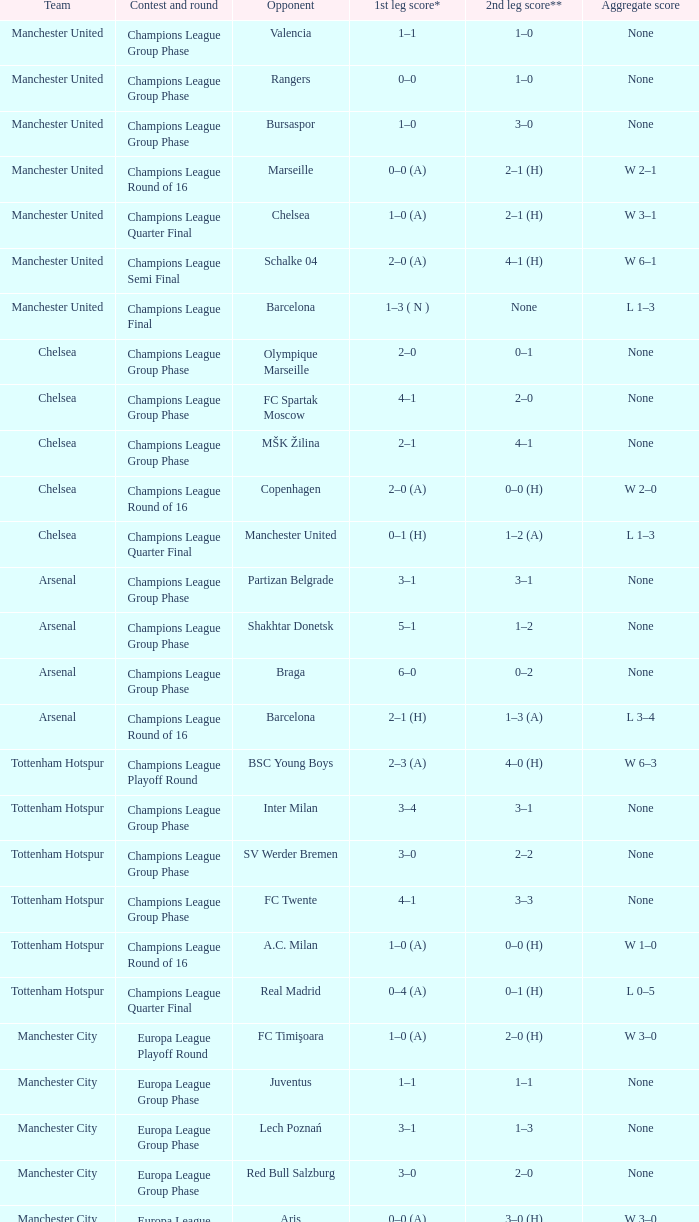How many goals did each team score in the first leg of the match between Liverpool and Steaua Bucureşti? 4–1. 